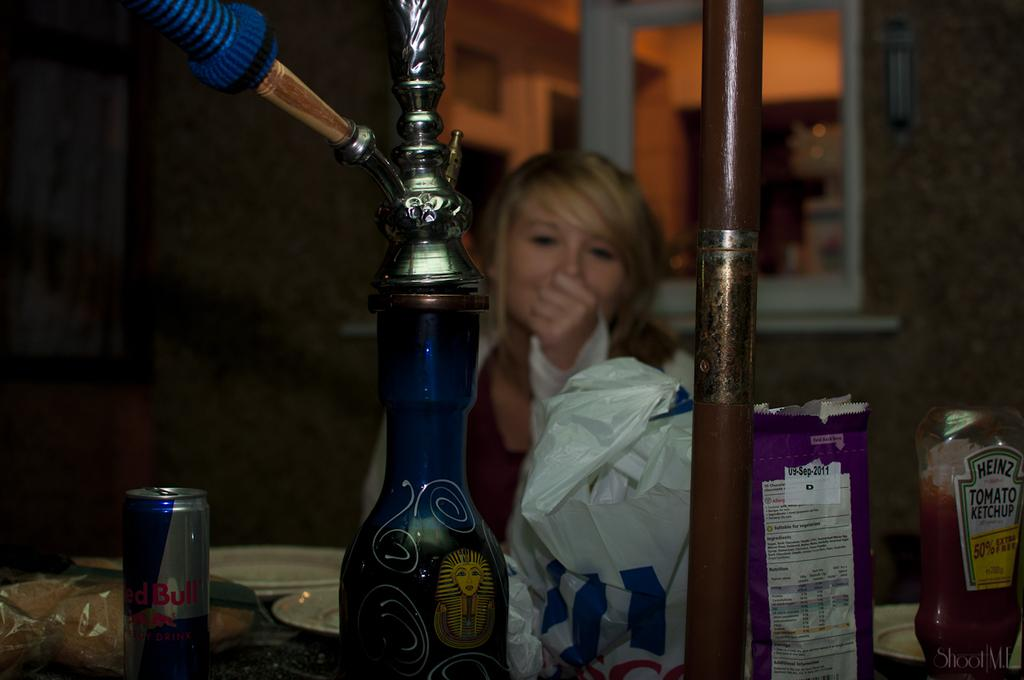<image>
Present a compact description of the photo's key features. a girl covering her mouth next to a table with Red Bull on it 